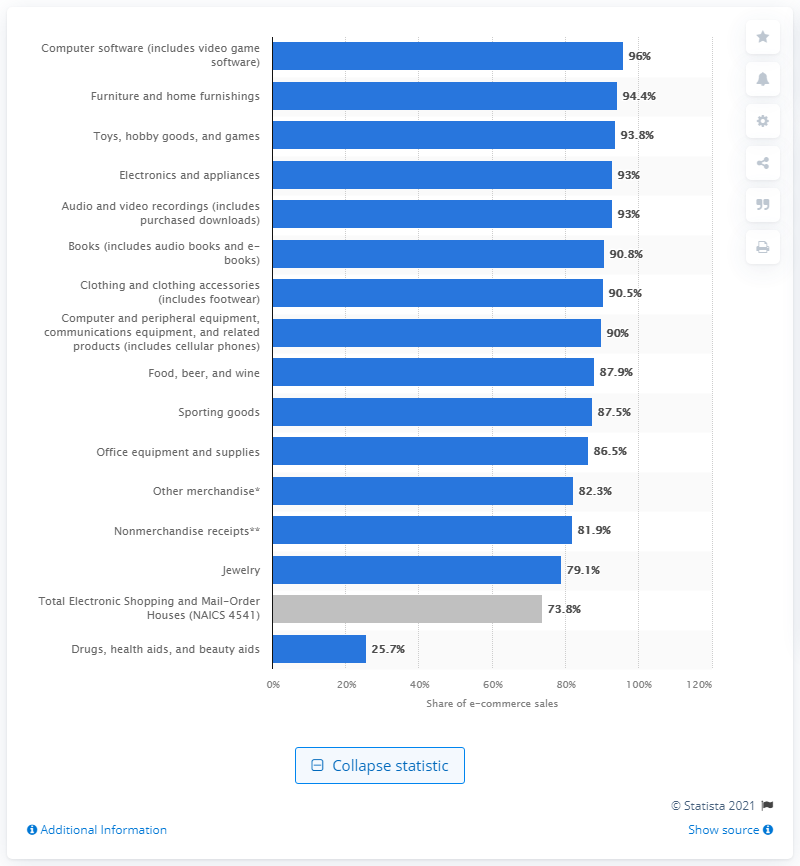Highlight a few significant elements in this photo. In 2018, e-commerce sales accounted for 93.8% of total electronics and appliances sales. 